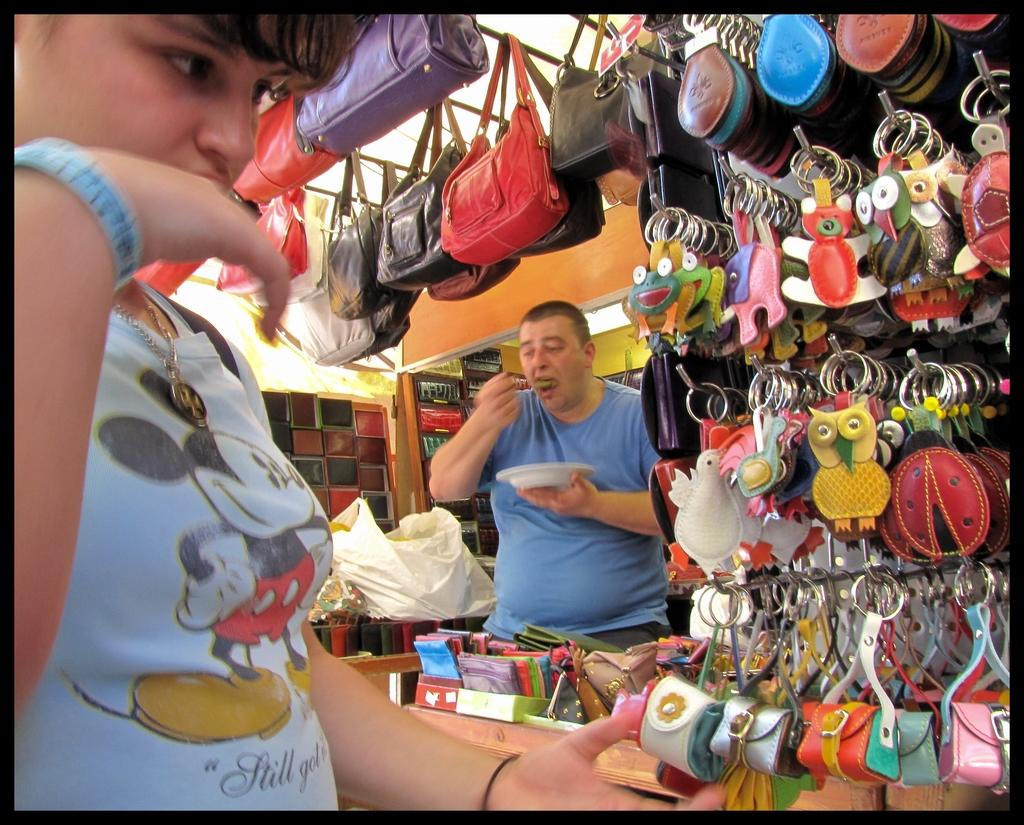Who is in the image? There is a woman in the image. What is the woman doing in the image? The woman is checking a key chain in the image. Where is the key chain located in relation to other objects? The key chain is in front of a handbag in the image. What type of store can be seen in the image? The key chain store is present in the image. How many elbows can be seen on the woman in the image? There is no visible elbow on the woman in the image, as she is not shown in a position where her elbows would be visible. 